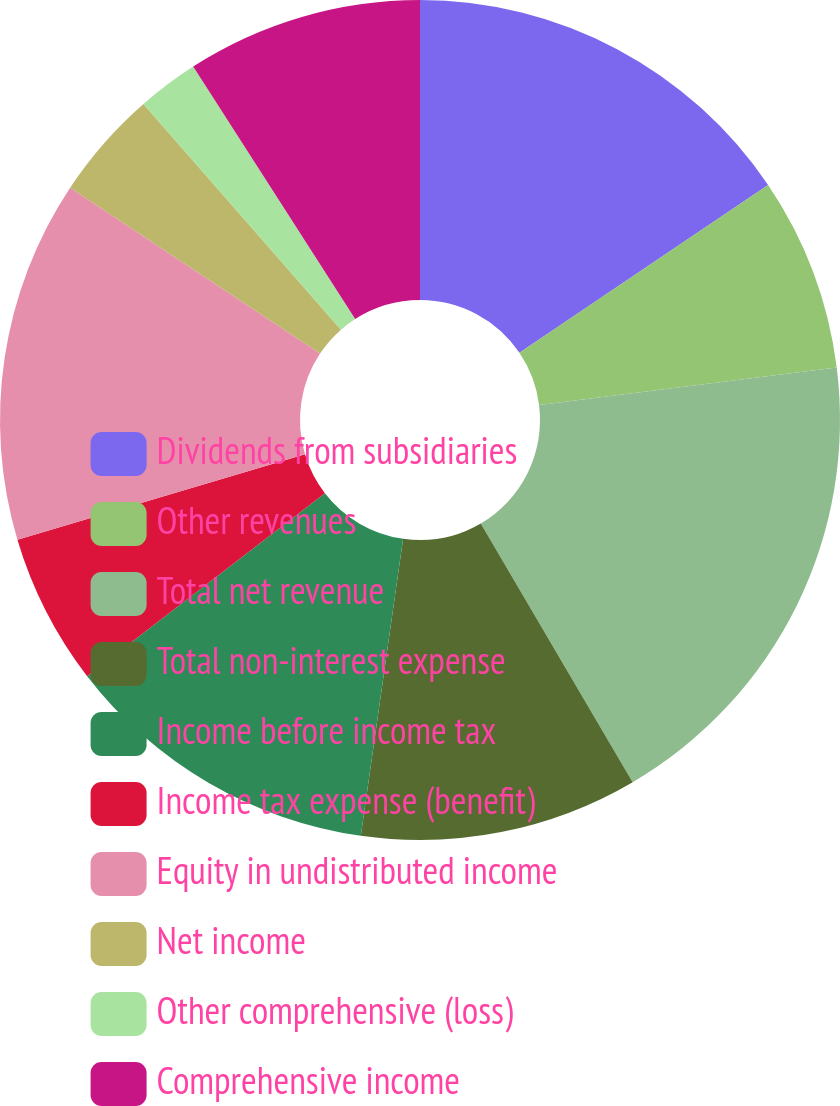Convert chart to OTSL. <chart><loc_0><loc_0><loc_500><loc_500><pie_chart><fcel>Dividends from subsidiaries<fcel>Other revenues<fcel>Total net revenue<fcel>Total non-interest expense<fcel>Income before income tax<fcel>Income tax expense (benefit)<fcel>Equity in undistributed income<fcel>Net income<fcel>Other comprehensive (loss)<fcel>Comprehensive income<nl><fcel>15.55%<fcel>7.46%<fcel>18.54%<fcel>10.7%<fcel>12.31%<fcel>5.84%<fcel>13.93%<fcel>4.23%<fcel>2.36%<fcel>9.08%<nl></chart> 